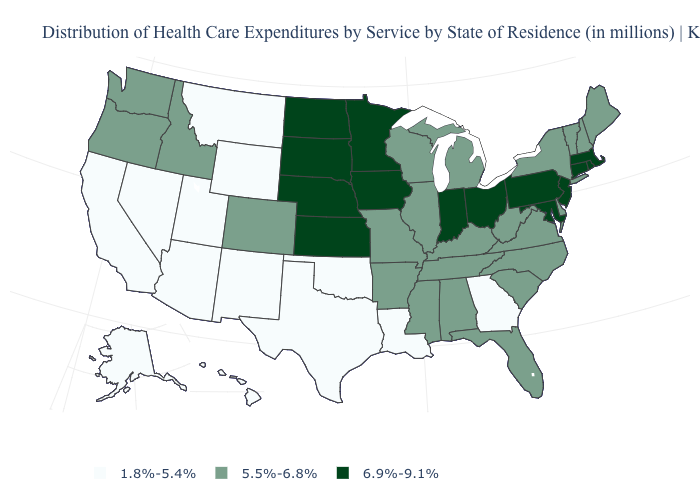Is the legend a continuous bar?
Give a very brief answer. No. What is the value of Arizona?
Short answer required. 1.8%-5.4%. Name the states that have a value in the range 5.5%-6.8%?
Short answer required. Alabama, Arkansas, Colorado, Delaware, Florida, Idaho, Illinois, Kentucky, Maine, Michigan, Mississippi, Missouri, New Hampshire, New York, North Carolina, Oregon, South Carolina, Tennessee, Vermont, Virginia, Washington, West Virginia, Wisconsin. Name the states that have a value in the range 6.9%-9.1%?
Give a very brief answer. Connecticut, Indiana, Iowa, Kansas, Maryland, Massachusetts, Minnesota, Nebraska, New Jersey, North Dakota, Ohio, Pennsylvania, Rhode Island, South Dakota. Name the states that have a value in the range 6.9%-9.1%?
Quick response, please. Connecticut, Indiana, Iowa, Kansas, Maryland, Massachusetts, Minnesota, Nebraska, New Jersey, North Dakota, Ohio, Pennsylvania, Rhode Island, South Dakota. Name the states that have a value in the range 5.5%-6.8%?
Give a very brief answer. Alabama, Arkansas, Colorado, Delaware, Florida, Idaho, Illinois, Kentucky, Maine, Michigan, Mississippi, Missouri, New Hampshire, New York, North Carolina, Oregon, South Carolina, Tennessee, Vermont, Virginia, Washington, West Virginia, Wisconsin. Does the first symbol in the legend represent the smallest category?
Keep it brief. Yes. Does the first symbol in the legend represent the smallest category?
Concise answer only. Yes. Does Texas have the lowest value in the South?
Write a very short answer. Yes. What is the highest value in states that border Iowa?
Answer briefly. 6.9%-9.1%. Is the legend a continuous bar?
Short answer required. No. Name the states that have a value in the range 1.8%-5.4%?
Be succinct. Alaska, Arizona, California, Georgia, Hawaii, Louisiana, Montana, Nevada, New Mexico, Oklahoma, Texas, Utah, Wyoming. Which states hav the highest value in the West?
Concise answer only. Colorado, Idaho, Oregon, Washington. What is the value of Massachusetts?
Keep it brief. 6.9%-9.1%. What is the value of Washington?
Write a very short answer. 5.5%-6.8%. 